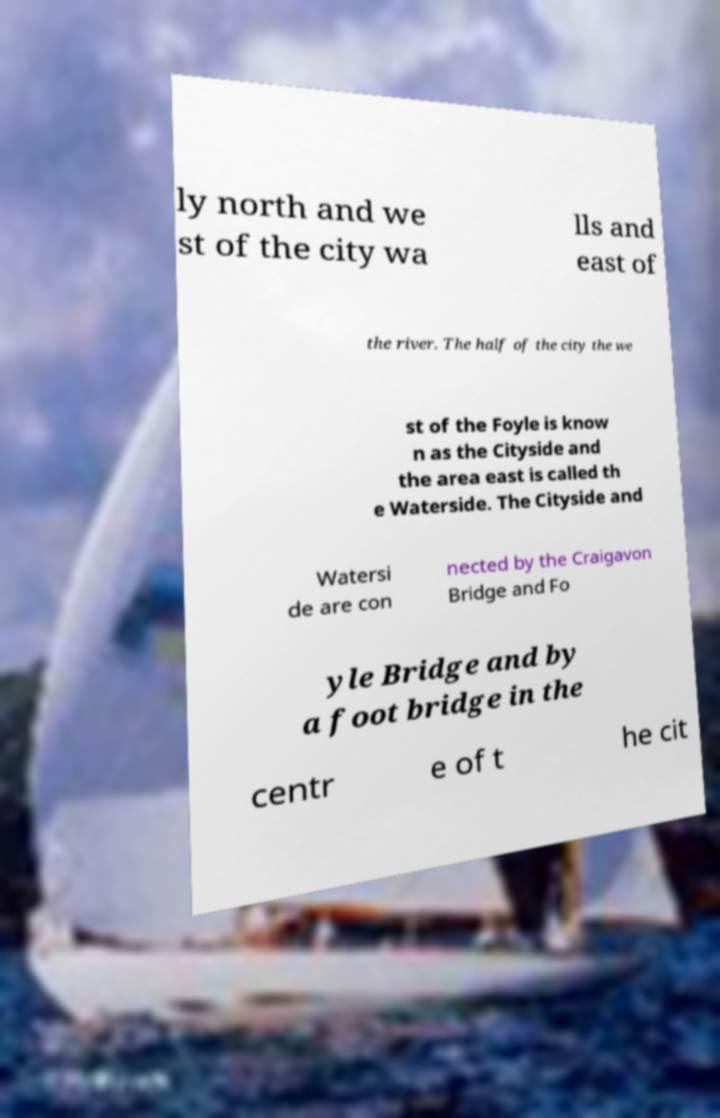For documentation purposes, I need the text within this image transcribed. Could you provide that? ly north and we st of the city wa lls and east of the river. The half of the city the we st of the Foyle is know n as the Cityside and the area east is called th e Waterside. The Cityside and Watersi de are con nected by the Craigavon Bridge and Fo yle Bridge and by a foot bridge in the centr e of t he cit 